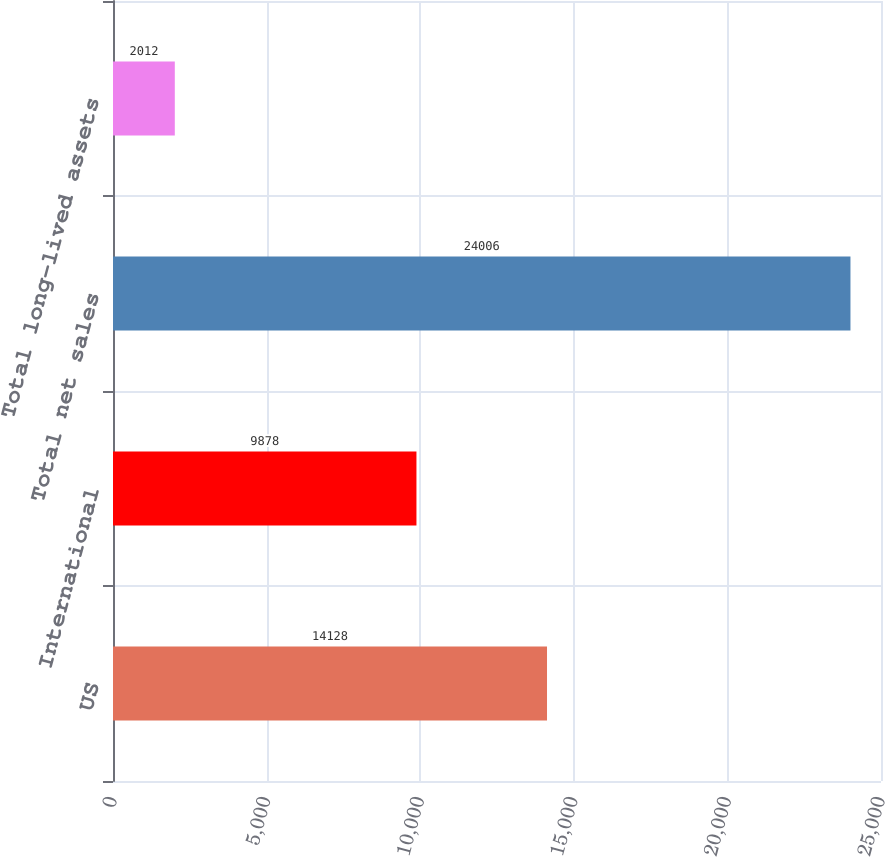Convert chart. <chart><loc_0><loc_0><loc_500><loc_500><bar_chart><fcel>US<fcel>International<fcel>Total net sales<fcel>Total long-lived assets<nl><fcel>14128<fcel>9878<fcel>24006<fcel>2012<nl></chart> 